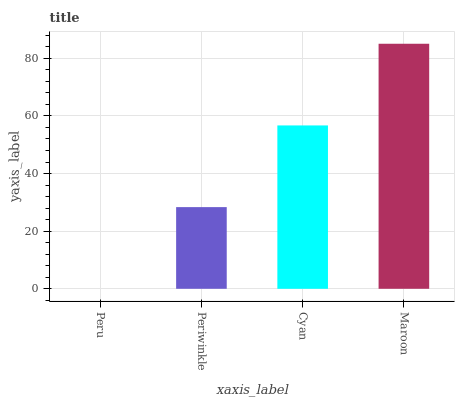Is Peru the minimum?
Answer yes or no. Yes. Is Maroon the maximum?
Answer yes or no. Yes. Is Periwinkle the minimum?
Answer yes or no. No. Is Periwinkle the maximum?
Answer yes or no. No. Is Periwinkle greater than Peru?
Answer yes or no. Yes. Is Peru less than Periwinkle?
Answer yes or no. Yes. Is Peru greater than Periwinkle?
Answer yes or no. No. Is Periwinkle less than Peru?
Answer yes or no. No. Is Cyan the high median?
Answer yes or no. Yes. Is Periwinkle the low median?
Answer yes or no. Yes. Is Peru the high median?
Answer yes or no. No. Is Cyan the low median?
Answer yes or no. No. 